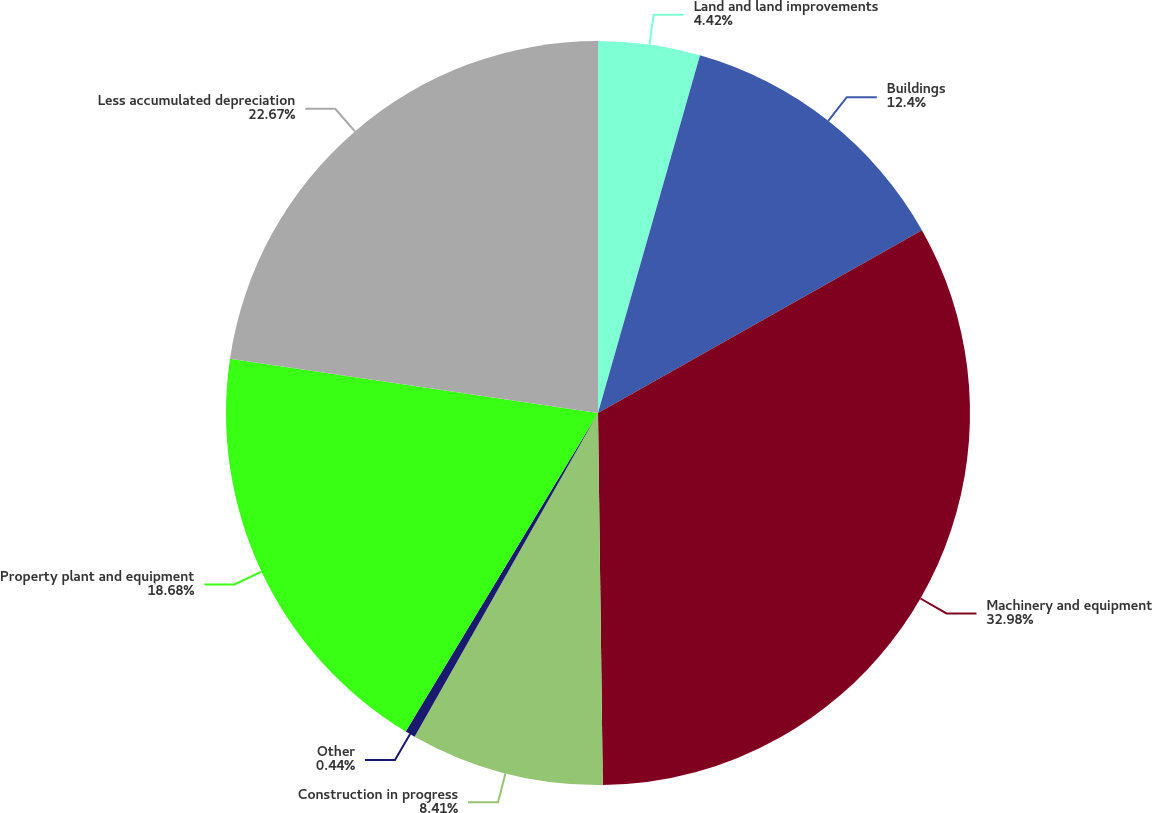Convert chart. <chart><loc_0><loc_0><loc_500><loc_500><pie_chart><fcel>Land and land improvements<fcel>Buildings<fcel>Machinery and equipment<fcel>Construction in progress<fcel>Other<fcel>Property plant and equipment<fcel>Less accumulated depreciation<nl><fcel>4.42%<fcel>12.4%<fcel>32.97%<fcel>8.41%<fcel>0.44%<fcel>18.68%<fcel>22.67%<nl></chart> 